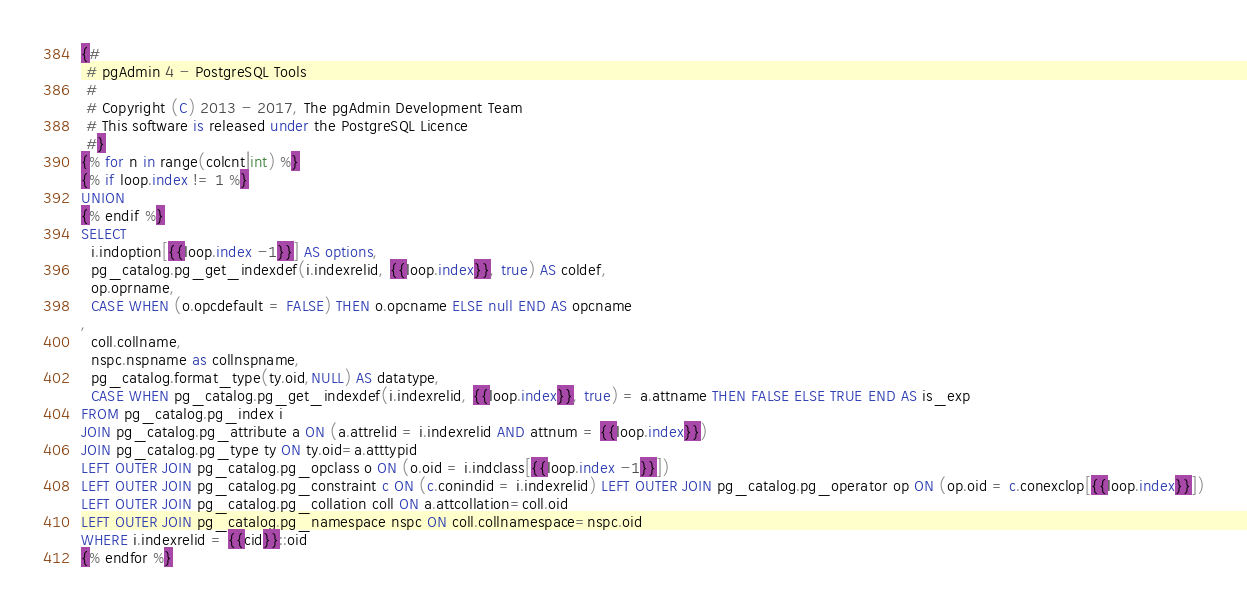Convert code to text. <code><loc_0><loc_0><loc_500><loc_500><_SQL_>{#
 # pgAdmin 4 - PostgreSQL Tools
 #
 # Copyright (C) 2013 - 2017, The pgAdmin Development Team
 # This software is released under the PostgreSQL Licence
 #}
{% for n in range(colcnt|int) %}
{% if loop.index != 1 %}
UNION
{% endif %}
SELECT
  i.indoption[{{loop.index -1}}] AS options,
  pg_catalog.pg_get_indexdef(i.indexrelid, {{loop.index}}, true) AS coldef,
  op.oprname,
  CASE WHEN (o.opcdefault = FALSE) THEN o.opcname ELSE null END AS opcname
,
  coll.collname,
  nspc.nspname as collnspname,
  pg_catalog.format_type(ty.oid,NULL) AS datatype,
  CASE WHEN pg_catalog.pg_get_indexdef(i.indexrelid, {{loop.index}}, true) = a.attname THEN FALSE ELSE TRUE END AS is_exp
FROM pg_catalog.pg_index i
JOIN pg_catalog.pg_attribute a ON (a.attrelid = i.indexrelid AND attnum = {{loop.index}})
JOIN pg_catalog.pg_type ty ON ty.oid=a.atttypid
LEFT OUTER JOIN pg_catalog.pg_opclass o ON (o.oid = i.indclass[{{loop.index -1}}])
LEFT OUTER JOIN pg_catalog.pg_constraint c ON (c.conindid = i.indexrelid) LEFT OUTER JOIN pg_catalog.pg_operator op ON (op.oid = c.conexclop[{{loop.index}}])
LEFT OUTER JOIN pg_catalog.pg_collation coll ON a.attcollation=coll.oid
LEFT OUTER JOIN pg_catalog.pg_namespace nspc ON coll.collnamespace=nspc.oid
WHERE i.indexrelid = {{cid}}::oid
{% endfor %}</code> 